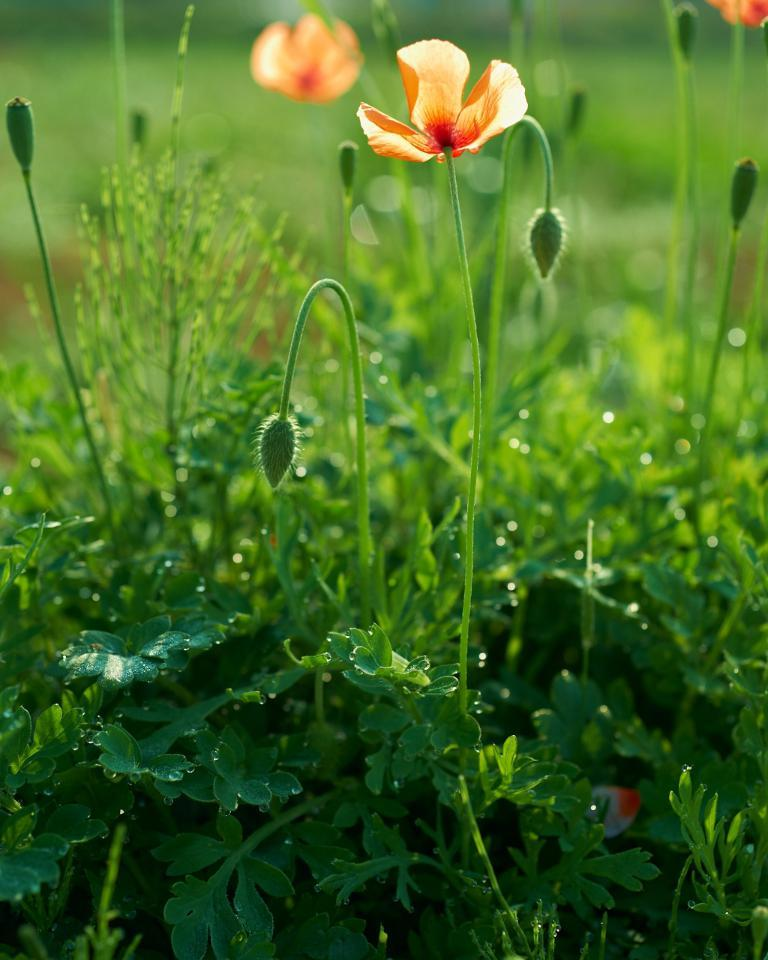What type of vegetation can be seen in the image? There are green-colored leaves and orange-colored flowers in the image. Can you describe the colors of the flowers? The flowers in the image are orange in color. How would you describe the overall clarity of the image? The image is slightly blurry in the background. What type of paint is being used by the society in the image? There is no reference to paint or a society in the image, so it is not possible to answer that question. 